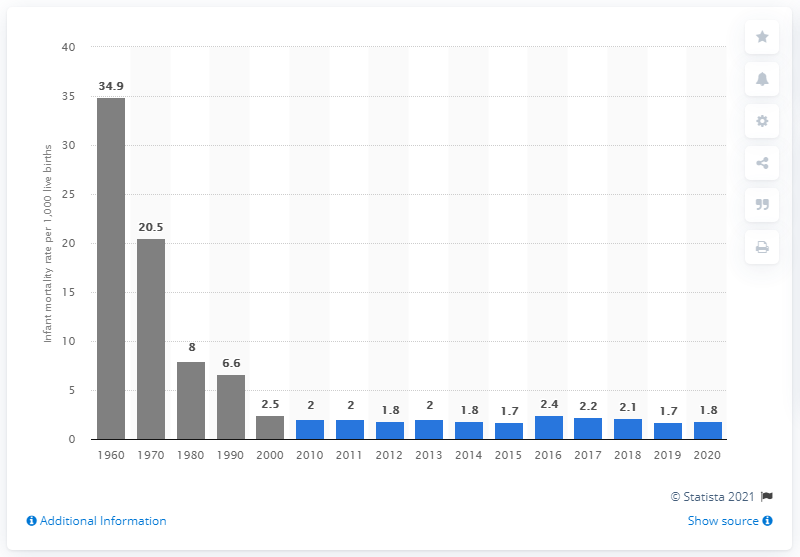List a handful of essential elements in this visual. In 2020, the infant mortality rate in Singapore was 1.8 per 1,000 live births. 